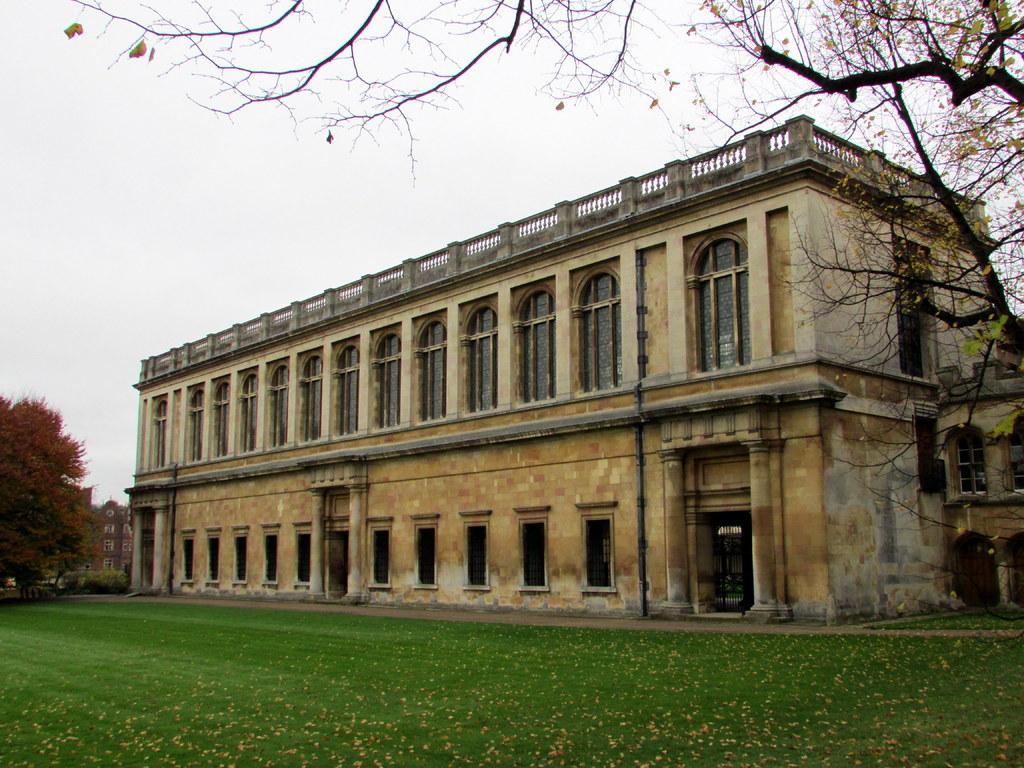Can you describe this image briefly? In this image there are buildings. At the bottom there is grass. In the background there are trees and sky. 